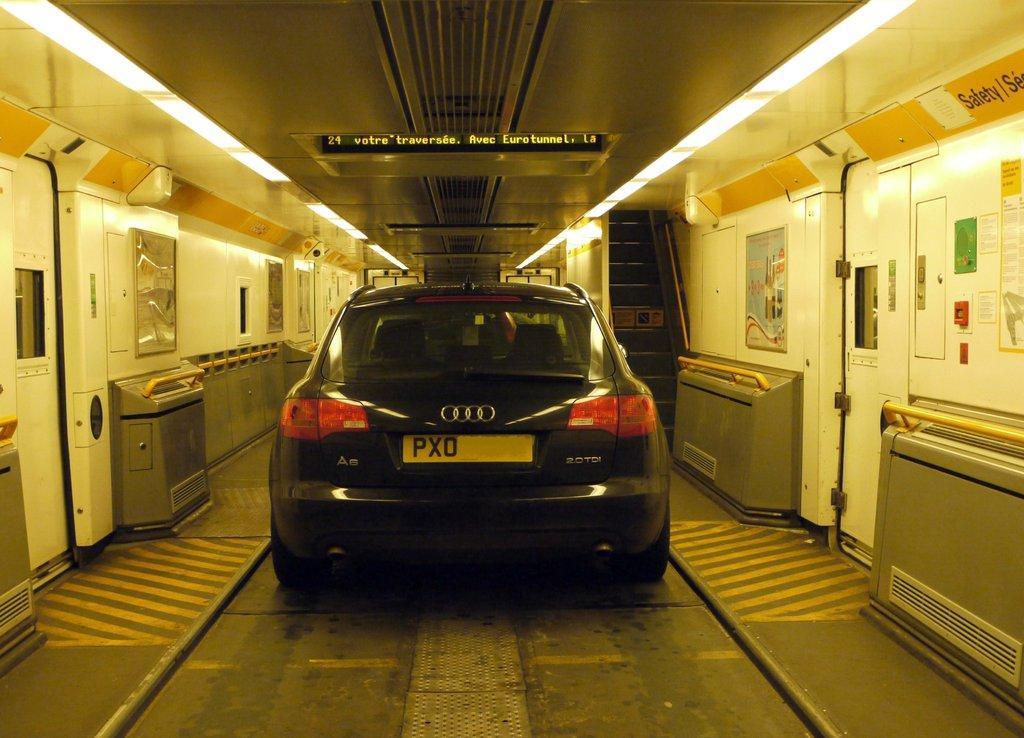How would you summarize this image in a sentence or two? In the center of the image we can see a car. At the bottom there is a road and we can see doors. At the top there are lights and we can see stairs. 